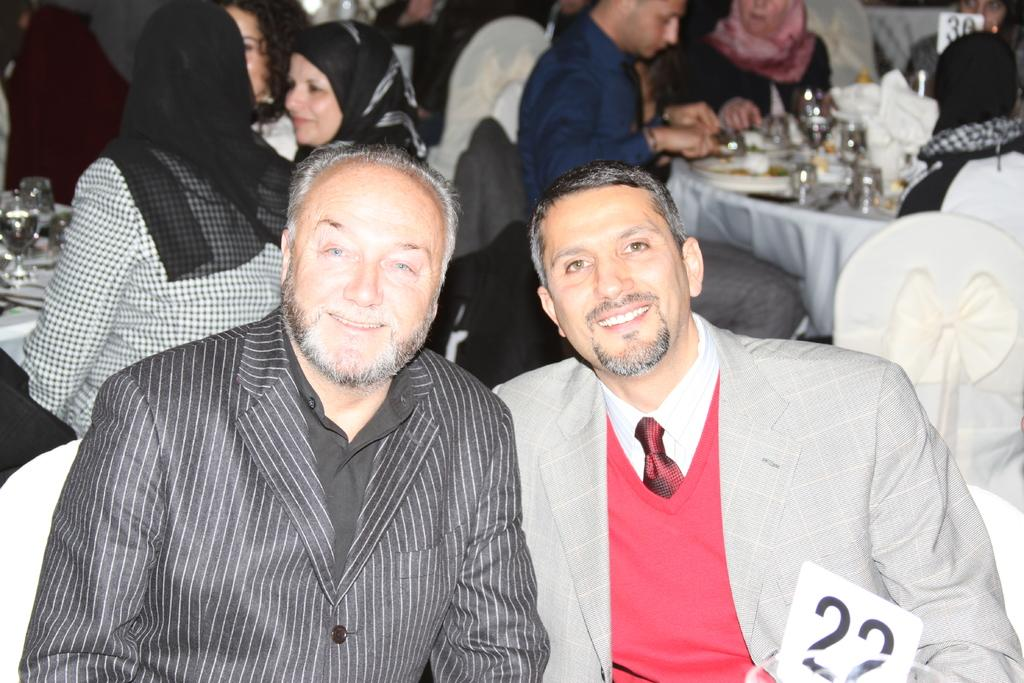What are the two men in the center of the image doing? The two men are sitting on chairs in the center of the image. What can be seen in the background of the image? There are many people and food visible in the background of the image. What type of furniture is present in the background of the image? There are tables and chairs in the background of the image. What is the rate at which the hydrant is being used in the image? There is no hydrant present in the image, so it is not possible to determine its usage rate. 